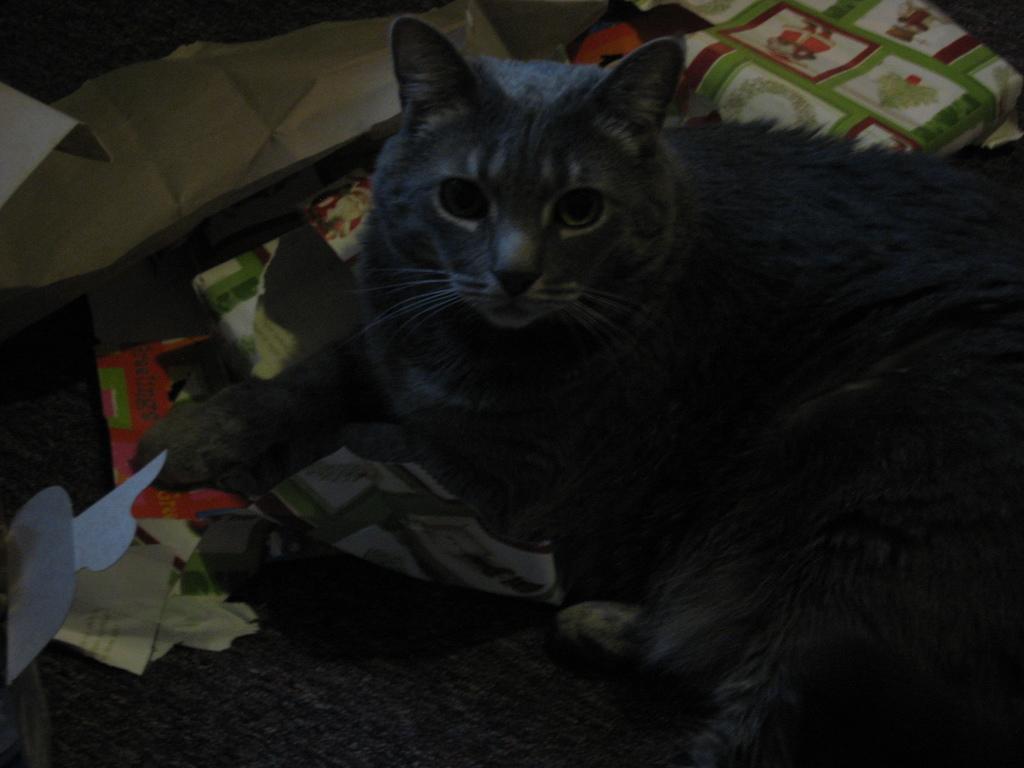In one or two sentences, can you explain what this image depicts? In this picture we can see a cat sitting on a cloth and looking at someone. 